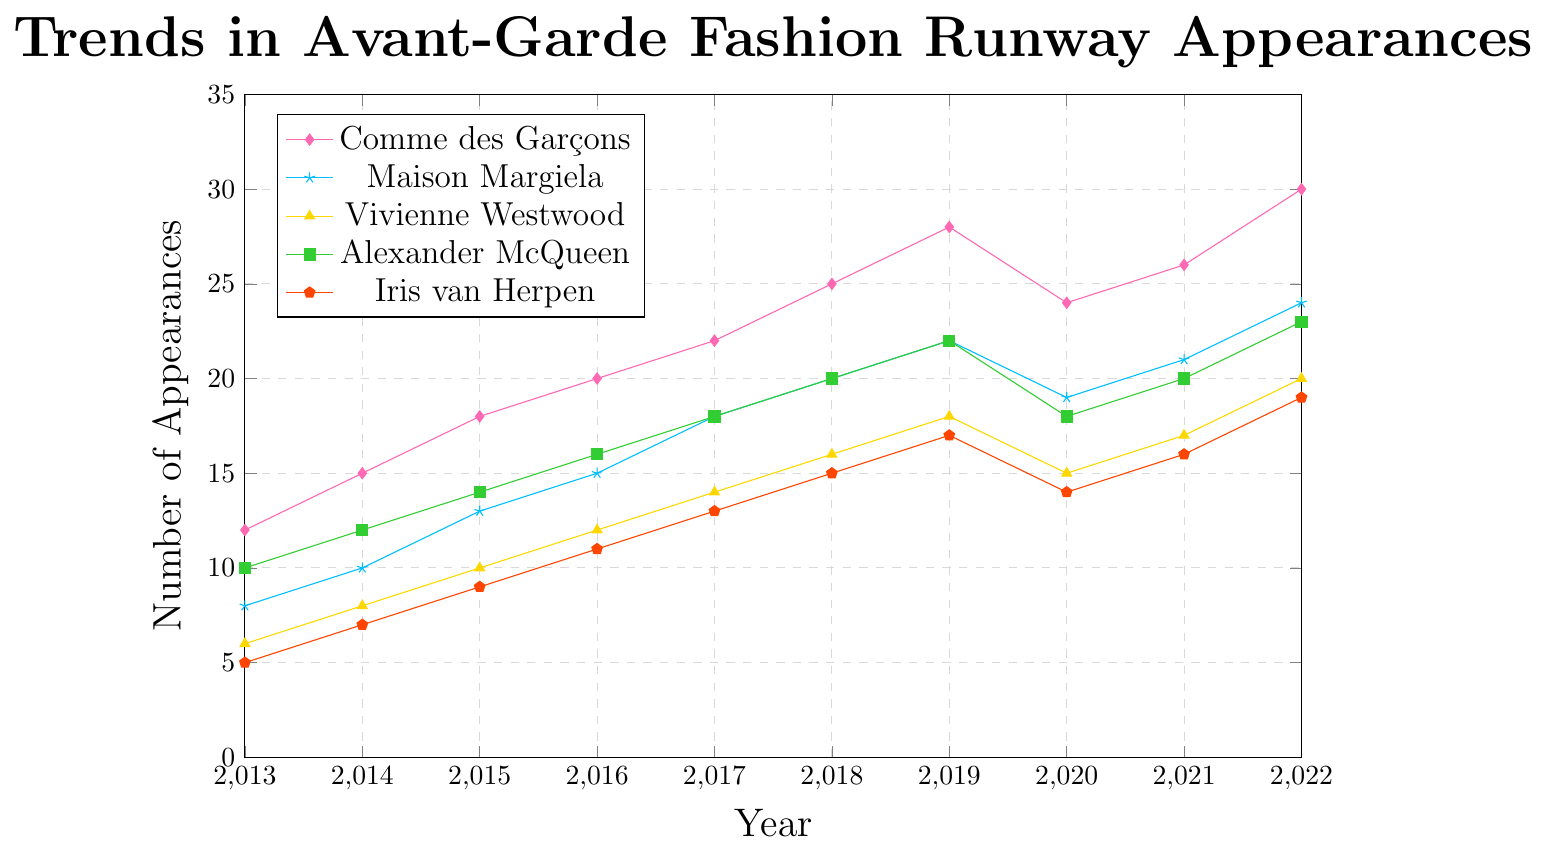What's the highest number of runway appearances for Comme des Garçons in the past decade? Look at the plot for the Como des Garçons line, the highest point on the y-axis represents their peak appearances.
Answer: 30 Which designer had the lowest number of appearances in 2013? Compare the points for all designers at the x-axis value 2013; find the lowest y-axis value.
Answer: Gareth Pugh By how many appearances did Alexander McQueen increase from 2013 to 2022? Subtract the y-axis value in 2013 from the y-axis value in 2022 for Alexander McQueen. 23 - 10 = 13
Answer: 13 Which designer had the most significant drop in appearances between 2019 and 2020? Look at the slopes between 2019 and 2020 for all designers, identify the steepest downward slope.
Answer: Comme des Garçons What is the average number of runway appearances for Vivienne Westwood from 2013 to 2022? Sum the values for Vivienne Westwood from 2013 to 2022 and divide by 10 (years). (6+8+10+12+14+16+18+15+17+20)/10 = 13.6
Answer: 13.6 Which designer's trend line is consistently increasing without any drops? Identify a line that doesn't have any downward movement across the entire x-axis span.
Answer: None By how many appearances did Rick Owens increase from 2015 to 2018? Subtract the y-axis value for Rick Owens in 2015 from the y-axis value in 2018. (21-15) = 6
Answer: 6 Which designers had equal appearances in 2020? Look at the points for all designers at the x-axis value 2020; check for equal y-axis values.
Answer: Vivienne Westwood and Gareth Pugh Among the nine designers, who had the greatest increase in runway appearances from 2013 to 2022? Compare the difference between the values in 2022 and 2013 for each designer, identify the largest difference. Comme des Garçons (30-12) = 18
Answer: Comme des Garçons Which designer has the most frequent fluctuations in their appearance trend? Identify the line with the most changes in direction (up and down) over the decade.
Answer: Comme des Garçons 